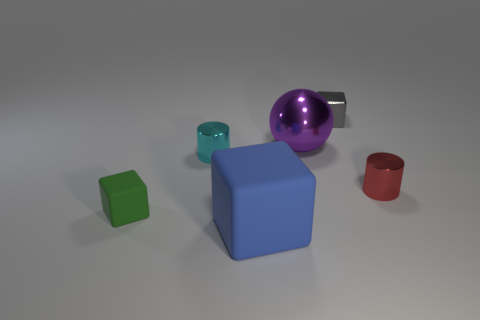Add 3 red things. How many objects exist? 9 Subtract all cylinders. How many objects are left? 4 Add 5 blue matte blocks. How many blue matte blocks exist? 6 Subtract 0 brown cylinders. How many objects are left? 6 Subtract all big purple cylinders. Subtract all large blue objects. How many objects are left? 5 Add 2 large blue blocks. How many large blue blocks are left? 3 